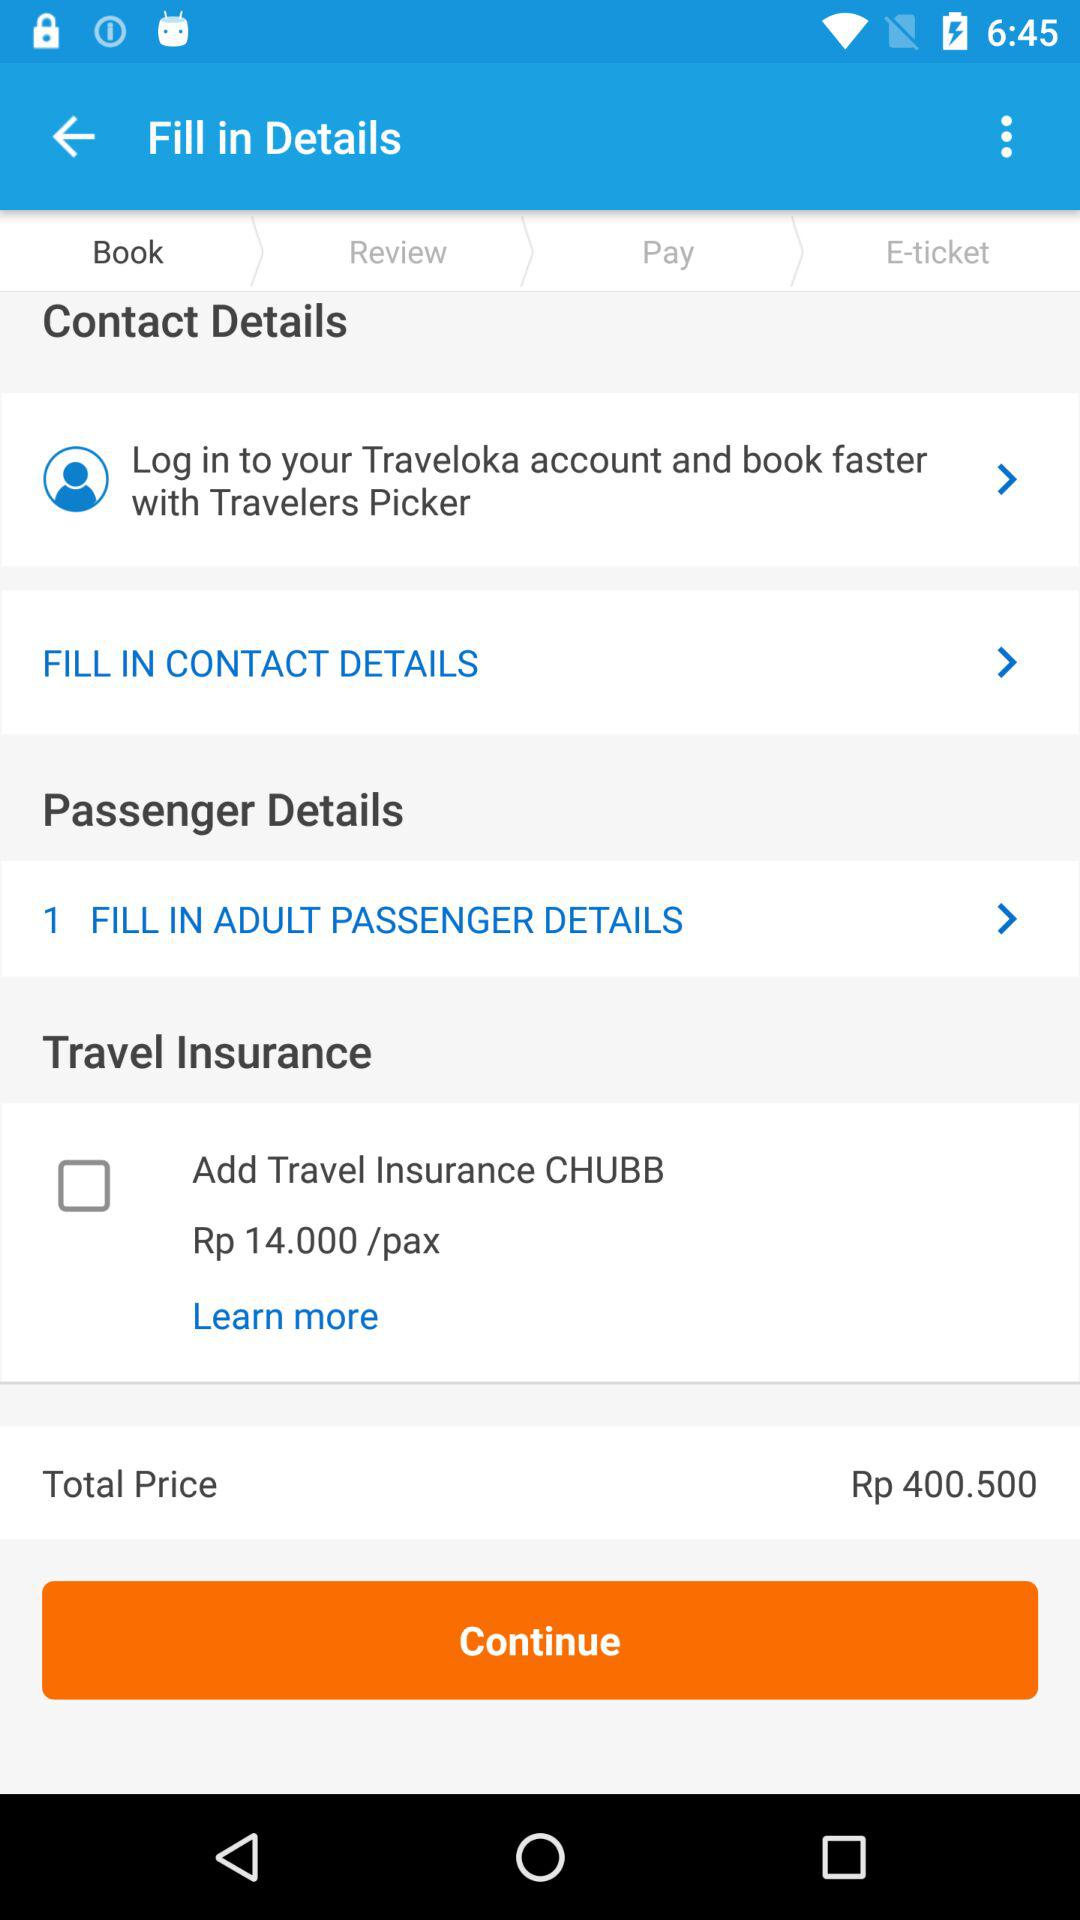What is the number of passengers filled in the adult passenger details? The number of passengers filled in the adult passenger details is 1. 